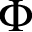Convert formula to latex. <formula><loc_0><loc_0><loc_500><loc_500>\Phi</formula> 